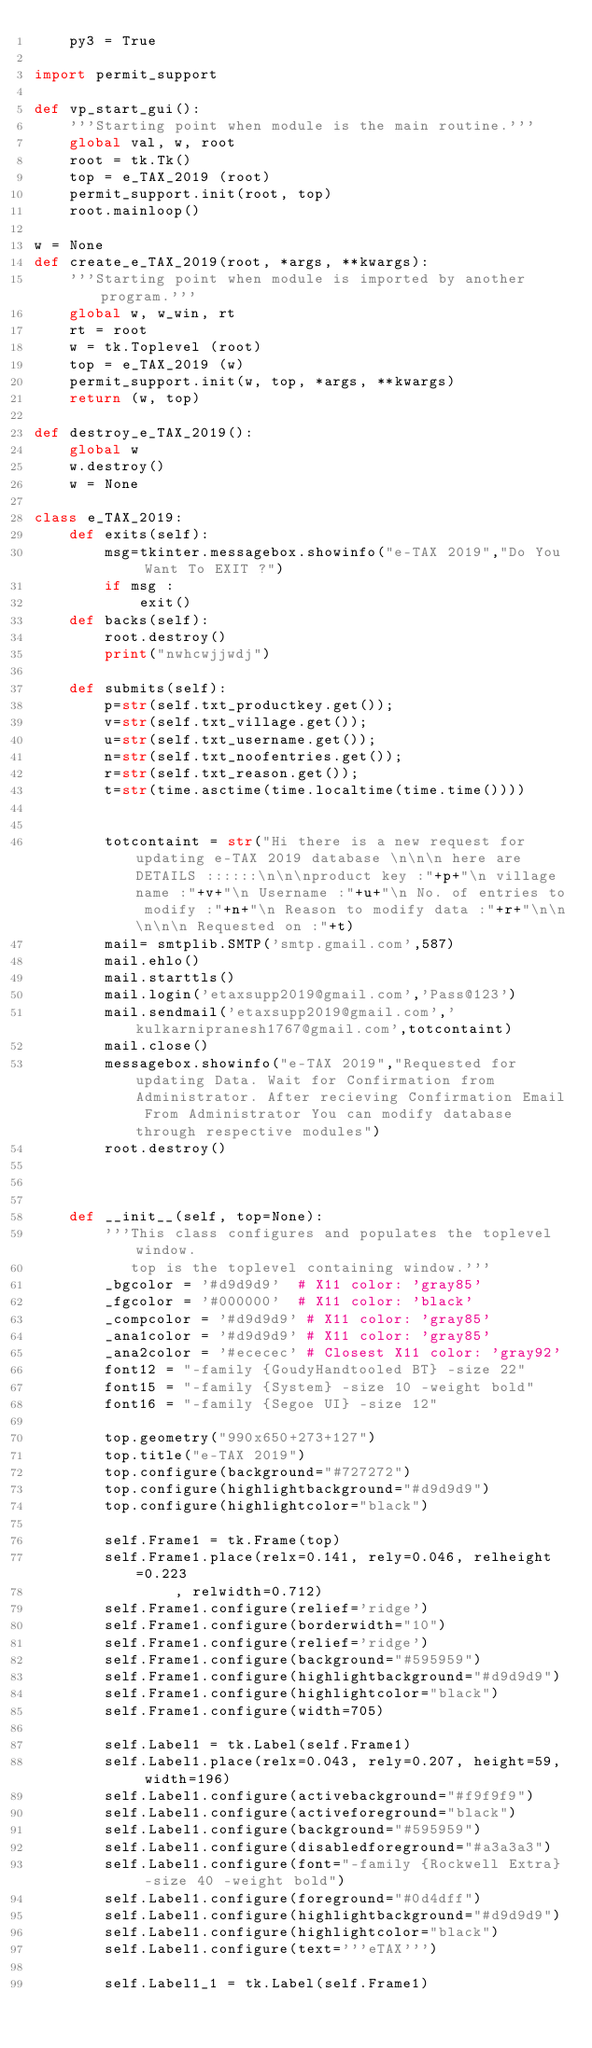Convert code to text. <code><loc_0><loc_0><loc_500><loc_500><_Python_>    py3 = True

import permit_support

def vp_start_gui():
    '''Starting point when module is the main routine.'''
    global val, w, root
    root = tk.Tk()
    top = e_TAX_2019 (root)
    permit_support.init(root, top)
    root.mainloop()

w = None
def create_e_TAX_2019(root, *args, **kwargs):
    '''Starting point when module is imported by another program.'''
    global w, w_win, rt
    rt = root
    w = tk.Toplevel (root)
    top = e_TAX_2019 (w)
    permit_support.init(w, top, *args, **kwargs)
    return (w, top)

def destroy_e_TAX_2019():
    global w
    w.destroy()
    w = None

class e_TAX_2019:
    def exits(self):
        msg=tkinter.messagebox.showinfo("e-TAX 2019","Do You Want To EXIT ?")
        if msg :
            exit()
    def backs(self):
        root.destroy()
        print("nwhcwjjwdj")

    def submits(self):
        p=str(self.txt_productkey.get());
        v=str(self.txt_village.get());
        u=str(self.txt_username.get());
        n=str(self.txt_noofentries.get());
        r=str(self.txt_reason.get());
        t=str(time.asctime(time.localtime(time.time())))


        totcontaint = str("Hi there is a new request for updating e-TAX 2019 database \n\n\n here are DETAILS ::::::\n\n\nproduct key :"+p+"\n village name :"+v+"\n Username :"+u+"\n No. of entries to modify :"+n+"\n Reason to modify data :"+r+"\n\n\n\n\n Requested on :"+t)
        mail= smtplib.SMTP('smtp.gmail.com',587)
        mail.ehlo()
        mail.starttls()
        mail.login('etaxsupp2019@gmail.com','Pass@123')
        mail.sendmail('etaxsupp2019@gmail.com','kulkarnipranesh1767@gmail.com',totcontaint)
        mail.close()
        messagebox.showinfo("e-TAX 2019","Requested for updating Data. Wait for Confirmation from Administrator. After recieving Confirmation Email From Administrator You can modify database through respective modules")
        root.destroy()



    def __init__(self, top=None):
        '''This class configures and populates the toplevel window.
           top is the toplevel containing window.'''
        _bgcolor = '#d9d9d9'  # X11 color: 'gray85'
        _fgcolor = '#000000'  # X11 color: 'black'
        _compcolor = '#d9d9d9' # X11 color: 'gray85'
        _ana1color = '#d9d9d9' # X11 color: 'gray85'
        _ana2color = '#ececec' # Closest X11 color: 'gray92'
        font12 = "-family {GoudyHandtooled BT} -size 22"
        font15 = "-family {System} -size 10 -weight bold"
        font16 = "-family {Segoe UI} -size 12"

        top.geometry("990x650+273+127")
        top.title("e-TAX 2019")
        top.configure(background="#727272")
        top.configure(highlightbackground="#d9d9d9")
        top.configure(highlightcolor="black")

        self.Frame1 = tk.Frame(top)
        self.Frame1.place(relx=0.141, rely=0.046, relheight=0.223
                , relwidth=0.712)
        self.Frame1.configure(relief='ridge')
        self.Frame1.configure(borderwidth="10")
        self.Frame1.configure(relief='ridge')
        self.Frame1.configure(background="#595959")
        self.Frame1.configure(highlightbackground="#d9d9d9")
        self.Frame1.configure(highlightcolor="black")
        self.Frame1.configure(width=705)

        self.Label1 = tk.Label(self.Frame1)
        self.Label1.place(relx=0.043, rely=0.207, height=59, width=196)
        self.Label1.configure(activebackground="#f9f9f9")
        self.Label1.configure(activeforeground="black")
        self.Label1.configure(background="#595959")
        self.Label1.configure(disabledforeground="#a3a3a3")
        self.Label1.configure(font="-family {Rockwell Extra} -size 40 -weight bold")
        self.Label1.configure(foreground="#0d4dff")
        self.Label1.configure(highlightbackground="#d9d9d9")
        self.Label1.configure(highlightcolor="black")
        self.Label1.configure(text='''eTAX''')

        self.Label1_1 = tk.Label(self.Frame1)</code> 